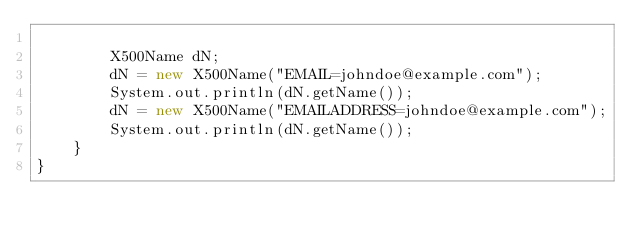Convert code to text. <code><loc_0><loc_0><loc_500><loc_500><_Java_>
        X500Name dN;
        dN = new X500Name("EMAIL=johndoe@example.com");
        System.out.println(dN.getName());
        dN = new X500Name("EMAILADDRESS=johndoe@example.com");
        System.out.println(dN.getName());
    }
}
</code> 